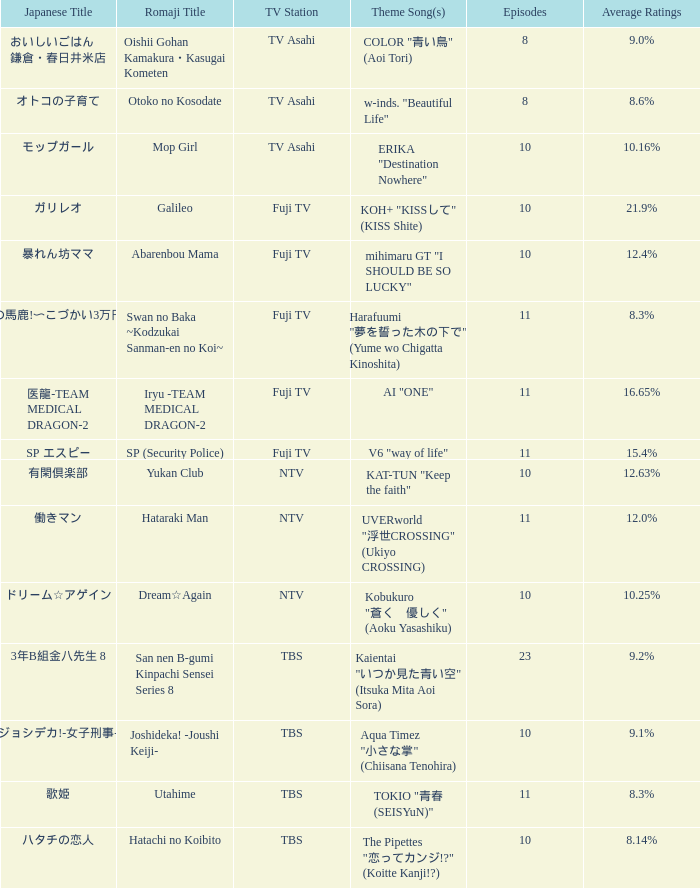What is the theme tune of the program on fuji tv station with mean ratings of 1 AI "ONE". 